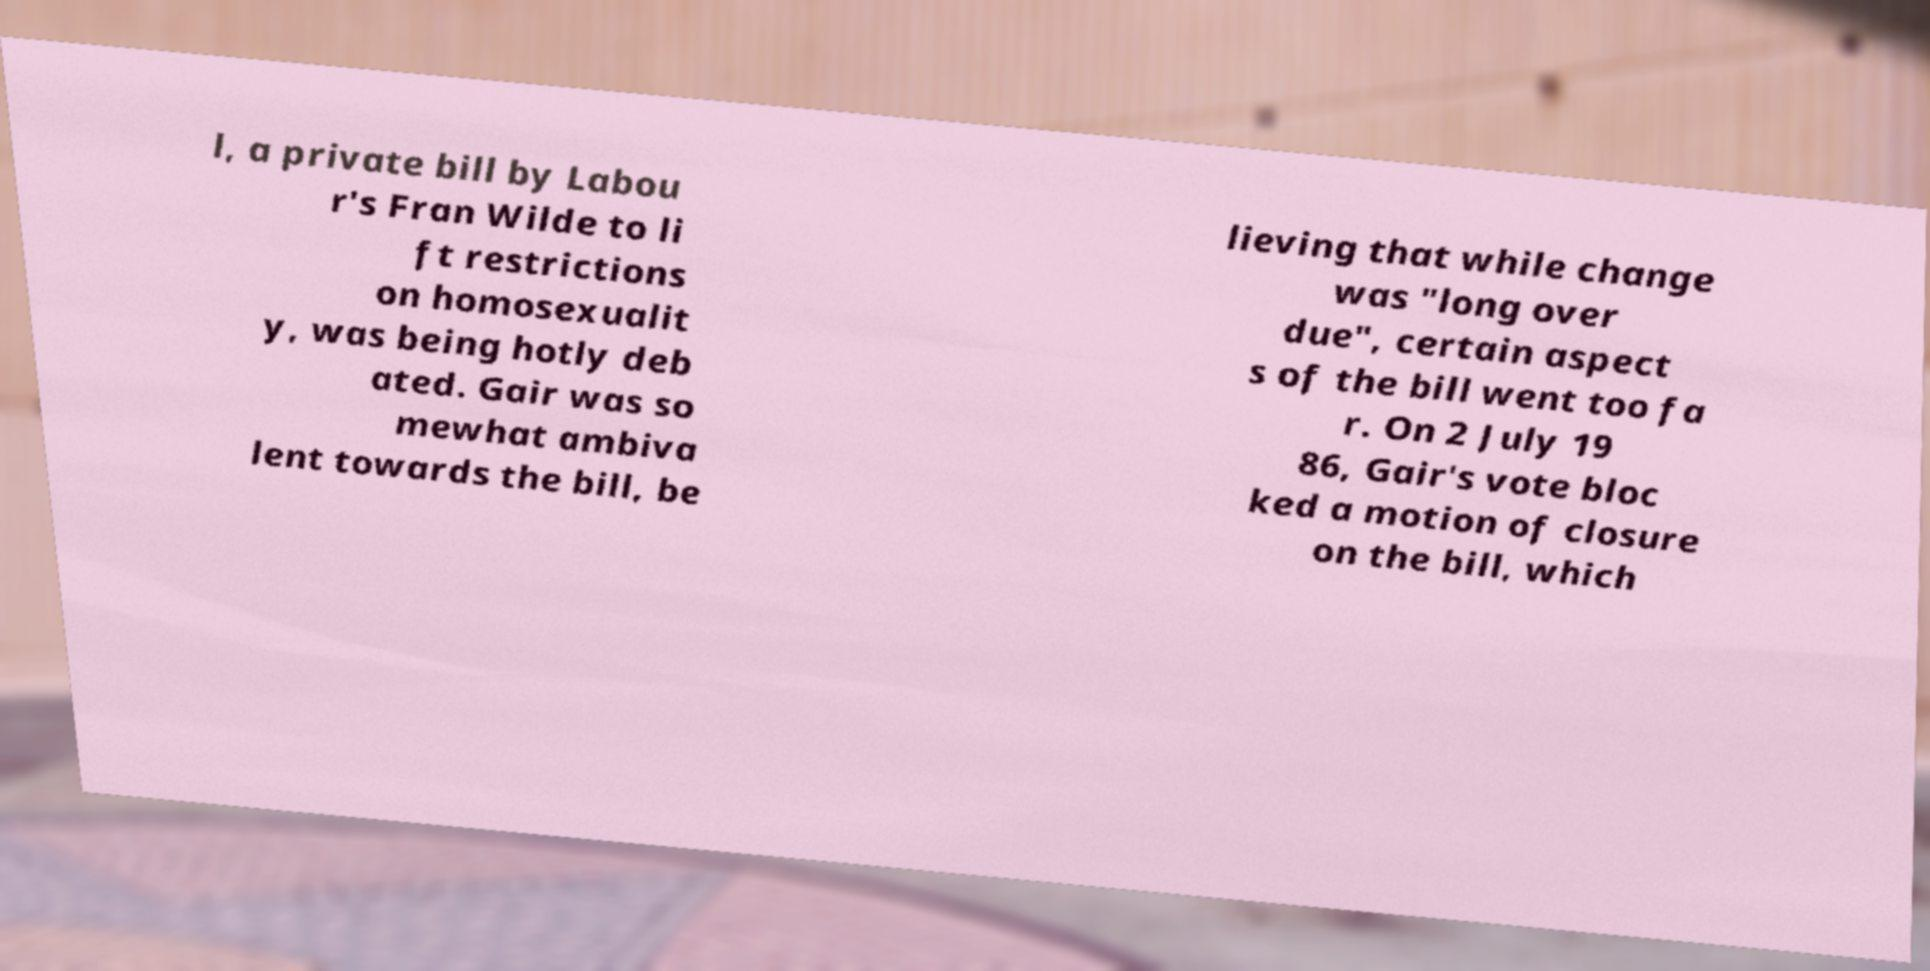I need the written content from this picture converted into text. Can you do that? l, a private bill by Labou r's Fran Wilde to li ft restrictions on homosexualit y, was being hotly deb ated. Gair was so mewhat ambiva lent towards the bill, be lieving that while change was "long over due", certain aspect s of the bill went too fa r. On 2 July 19 86, Gair's vote bloc ked a motion of closure on the bill, which 